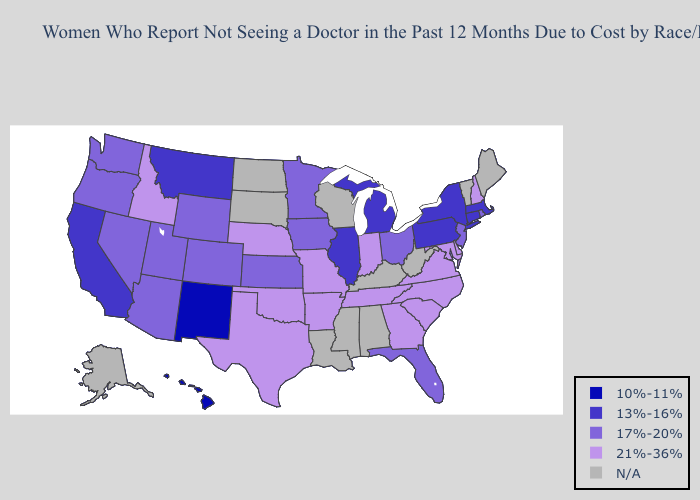Name the states that have a value in the range N/A?
Concise answer only. Alabama, Alaska, Kentucky, Louisiana, Maine, Mississippi, North Dakota, South Dakota, Vermont, West Virginia, Wisconsin. What is the lowest value in the South?
Give a very brief answer. 17%-20%. Does Florida have the highest value in the South?
Answer briefly. No. Among the states that border Iowa , does Missouri have the highest value?
Short answer required. Yes. Does Florida have the highest value in the South?
Give a very brief answer. No. Which states hav the highest value in the West?
Keep it brief. Idaho. Which states have the lowest value in the USA?
Give a very brief answer. Hawaii, New Mexico. Does the map have missing data?
Be succinct. Yes. Name the states that have a value in the range 10%-11%?
Keep it brief. Hawaii, New Mexico. What is the value of Nevada?
Keep it brief. 17%-20%. What is the value of Virginia?
Concise answer only. 21%-36%. Among the states that border Vermont , does New Hampshire have the highest value?
Concise answer only. Yes. What is the value of Oregon?
Answer briefly. 17%-20%. What is the highest value in the USA?
Short answer required. 21%-36%. What is the value of Maryland?
Give a very brief answer. 21%-36%. 